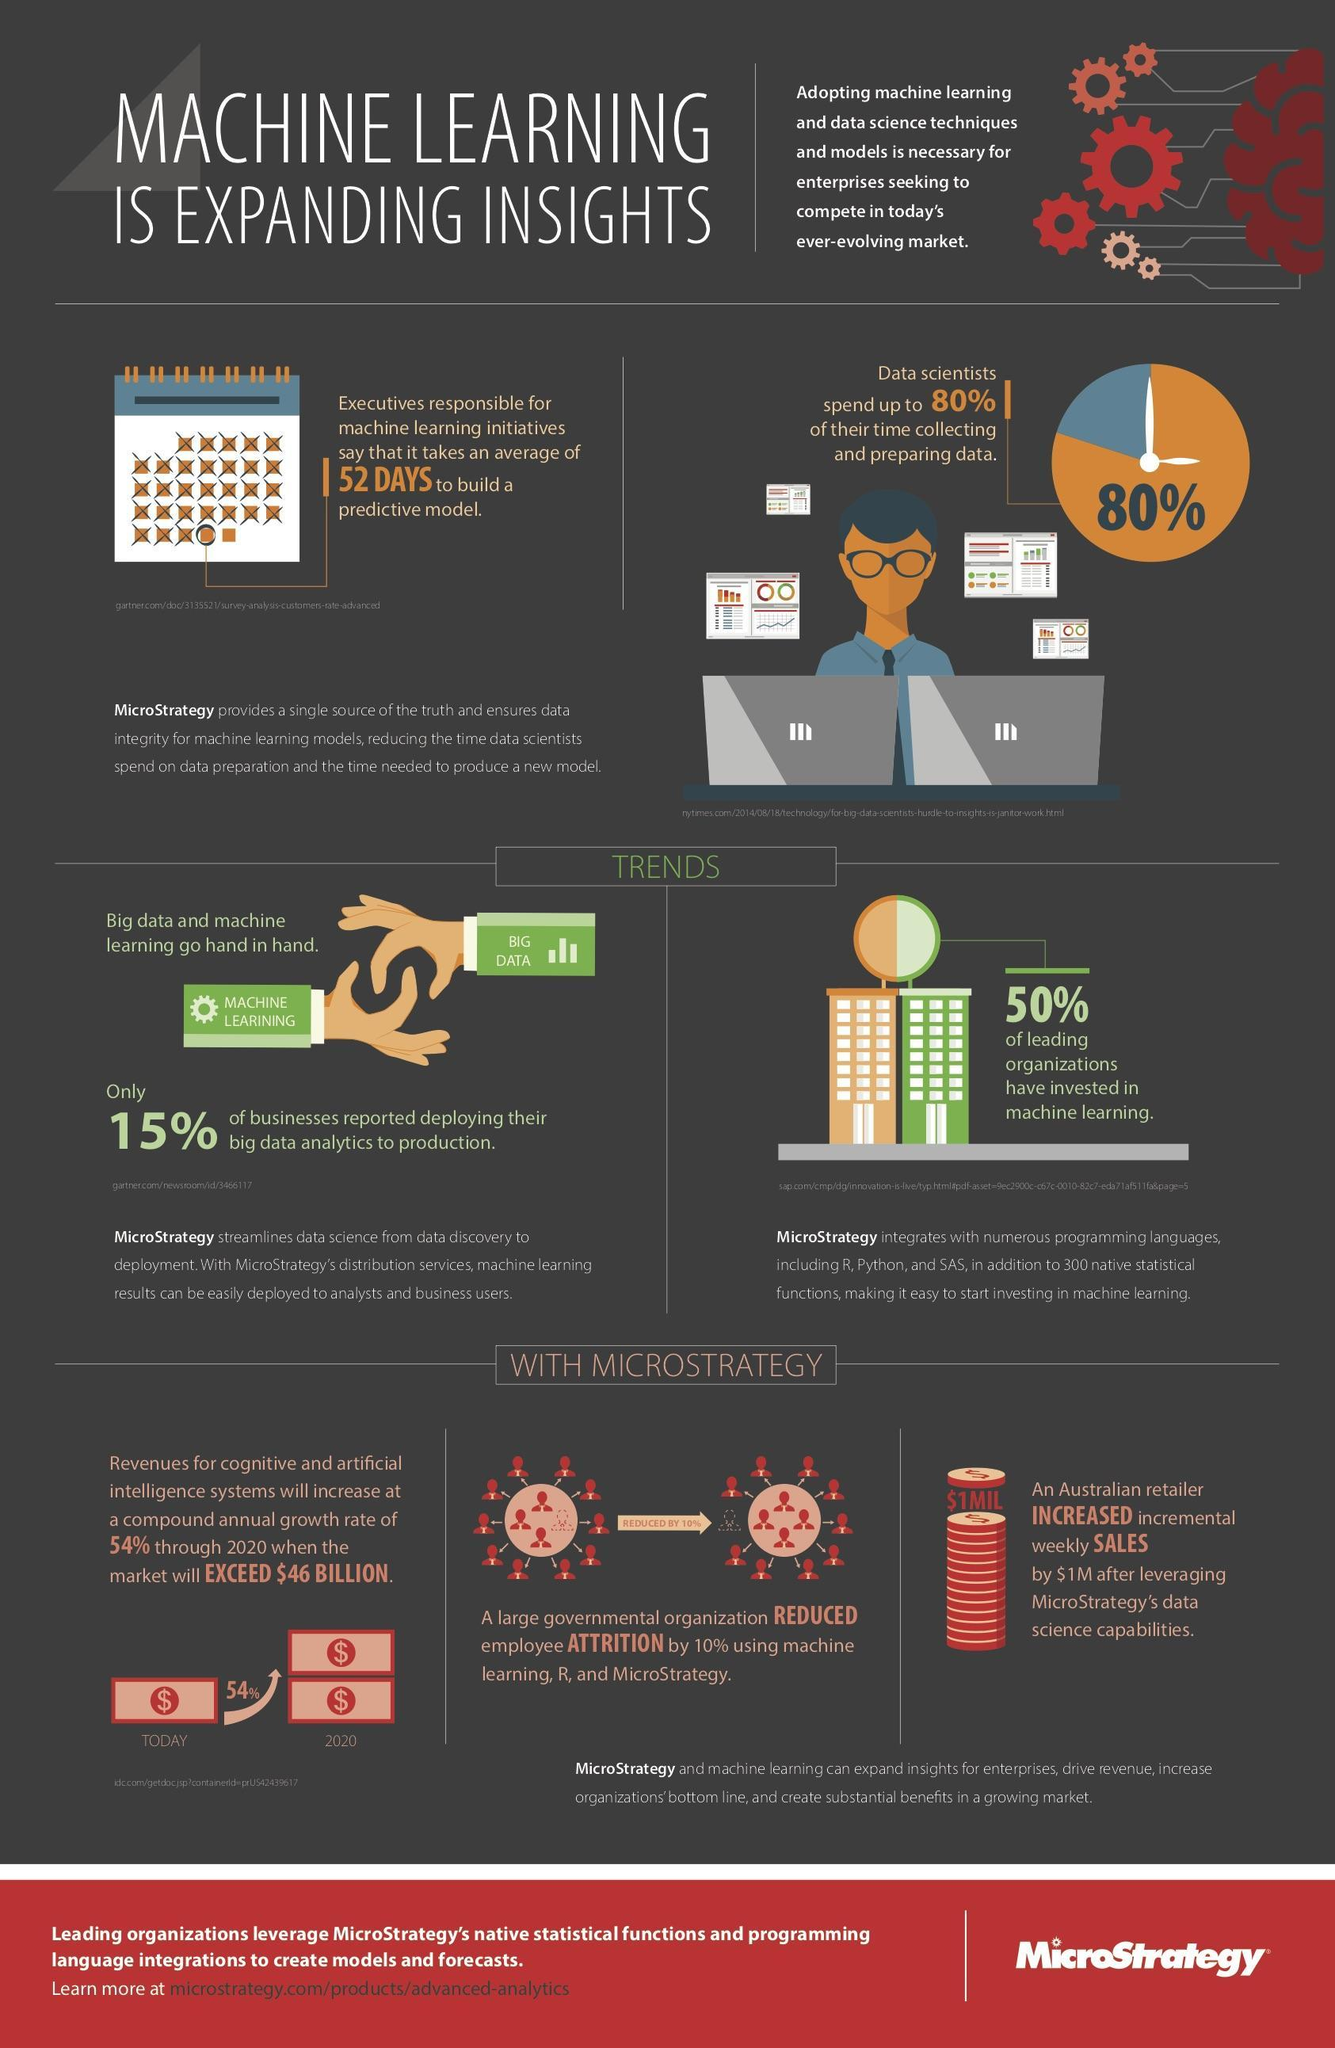What percentage of time do data scientists not engage in collecting and preparing data?
Answer the question with a short phrase. 20% What percent of businesses are not deploying their big data analytics to production? 85% 